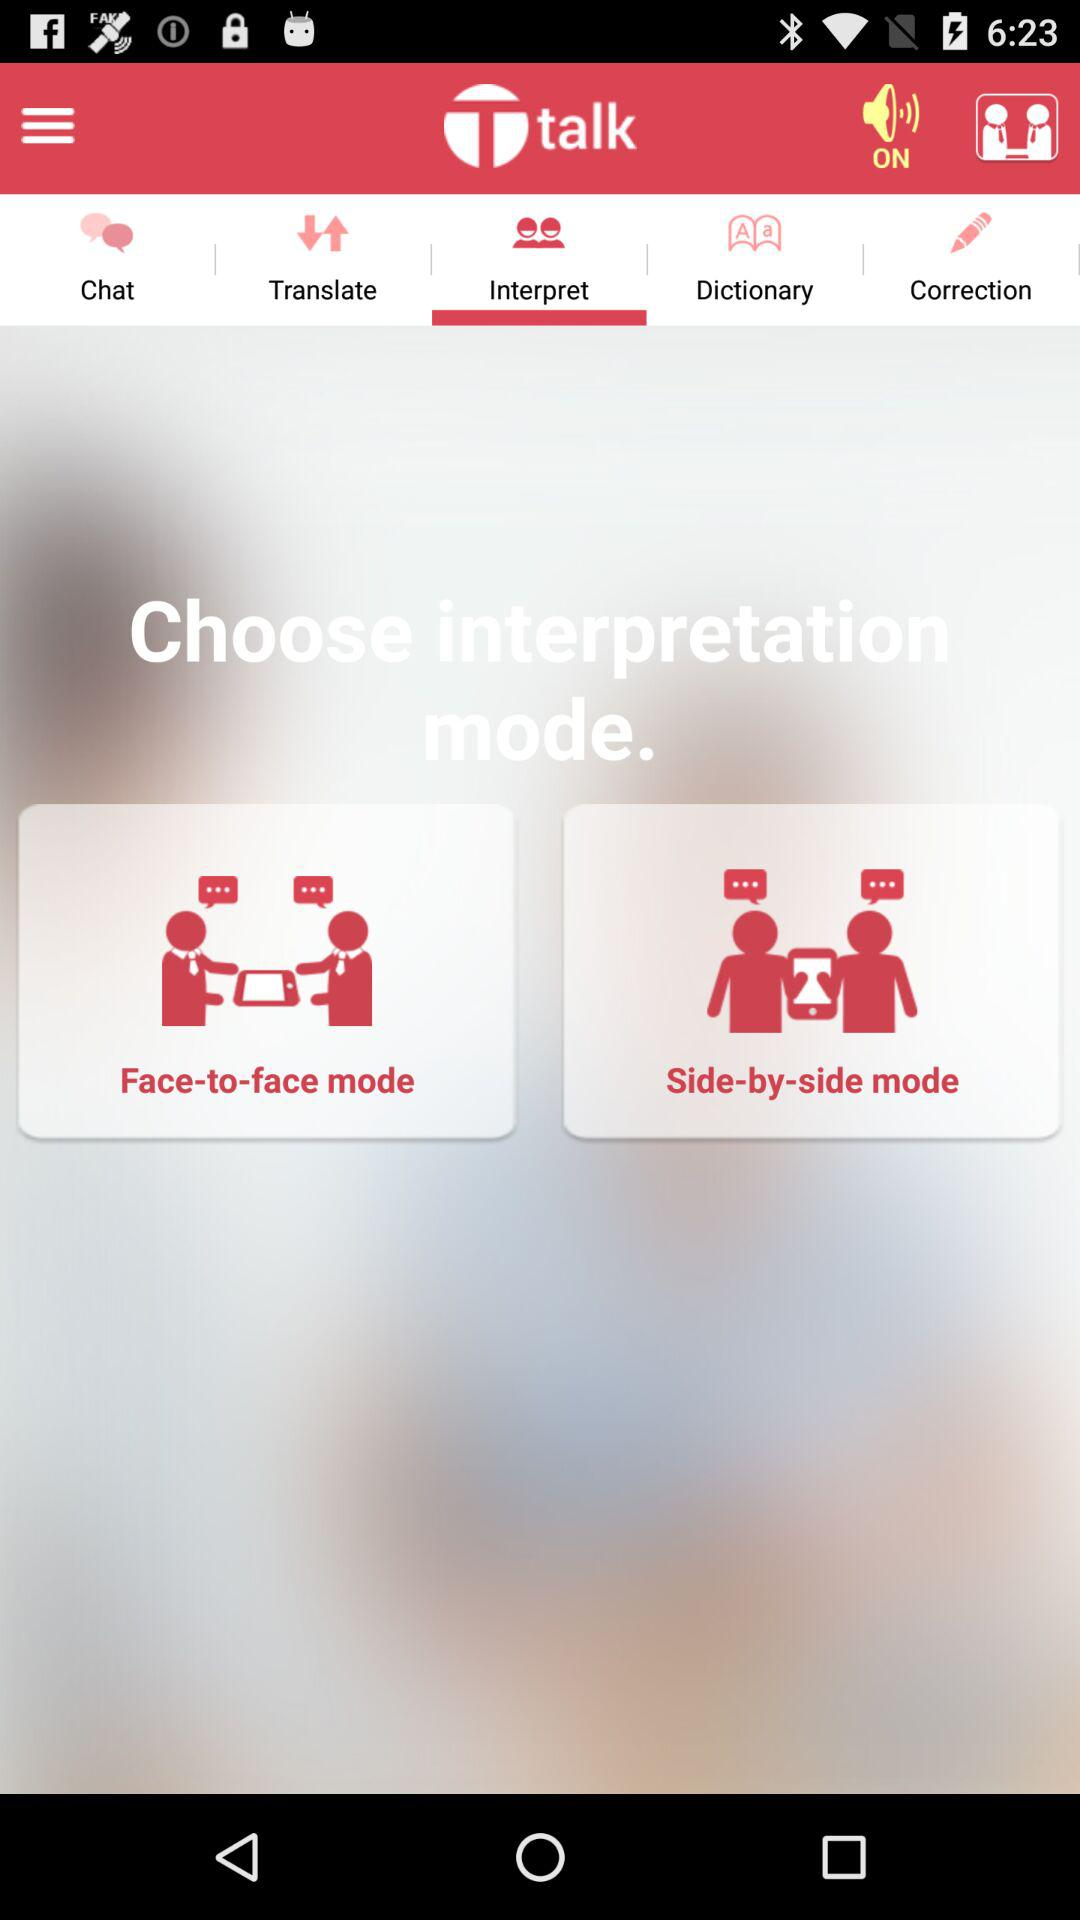Which are the different interpretation modes? The different interpretation modes are face-to-face mode and side-by-side mode. 